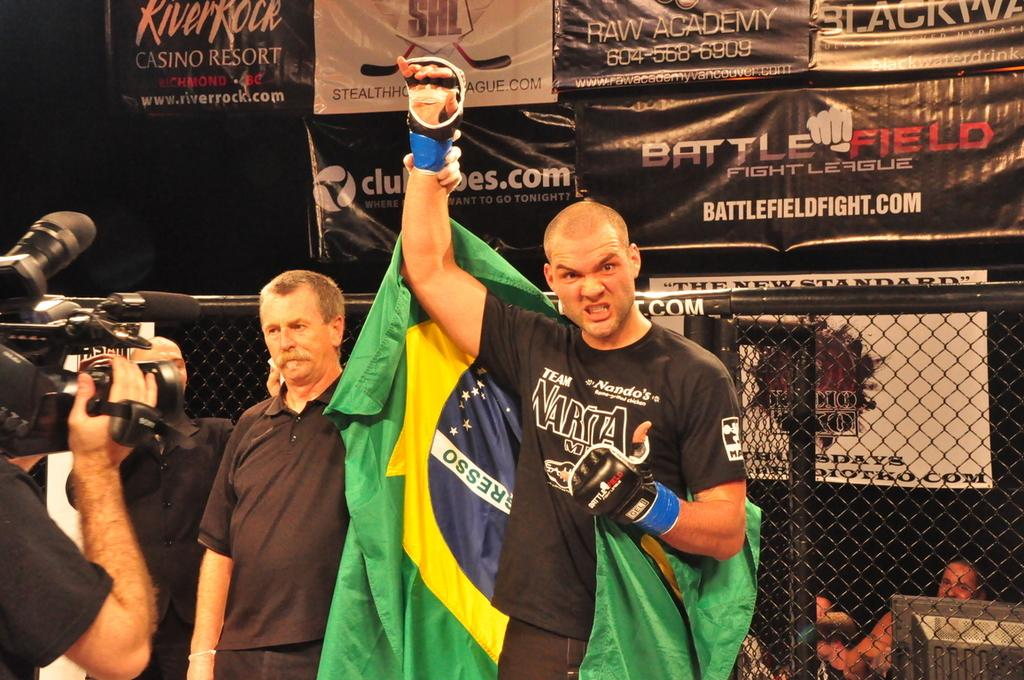Provide a one-sentence caption for the provided image. Behind a fighter is a banner that shows battlefieldfight.com. 